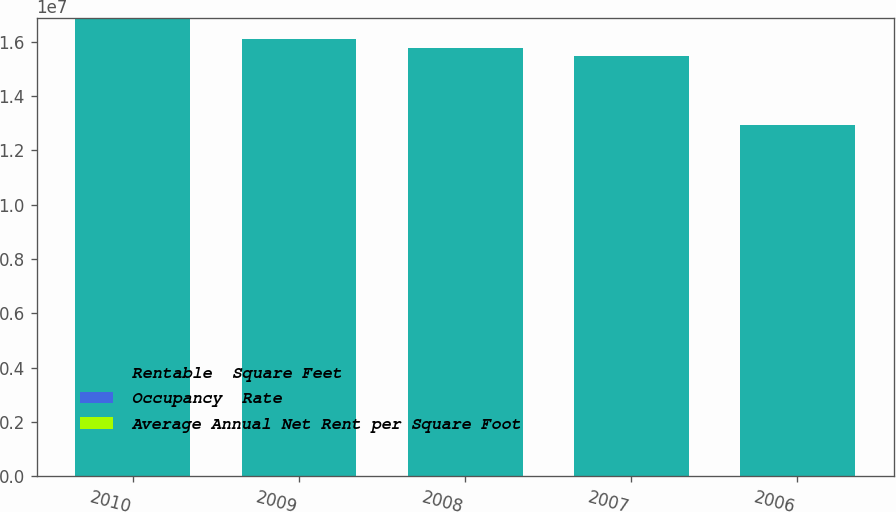Convert chart. <chart><loc_0><loc_0><loc_500><loc_500><stacked_bar_chart><ecel><fcel>2010<fcel>2009<fcel>2008<fcel>2007<fcel>2006<nl><fcel>Rentable  Square Feet<fcel>1.6866e+07<fcel>1.6107e+07<fcel>1.5755e+07<fcel>1.5463e+07<fcel>1.2933e+07<nl><fcel>Occupancy  Rate<fcel>92.1<fcel>91.5<fcel>91.9<fcel>94.1<fcel>92.9<nl><fcel>Average Annual Net Rent per Square Foot<fcel>15.68<fcel>15.3<fcel>14.52<fcel>14.12<fcel>13.48<nl></chart> 